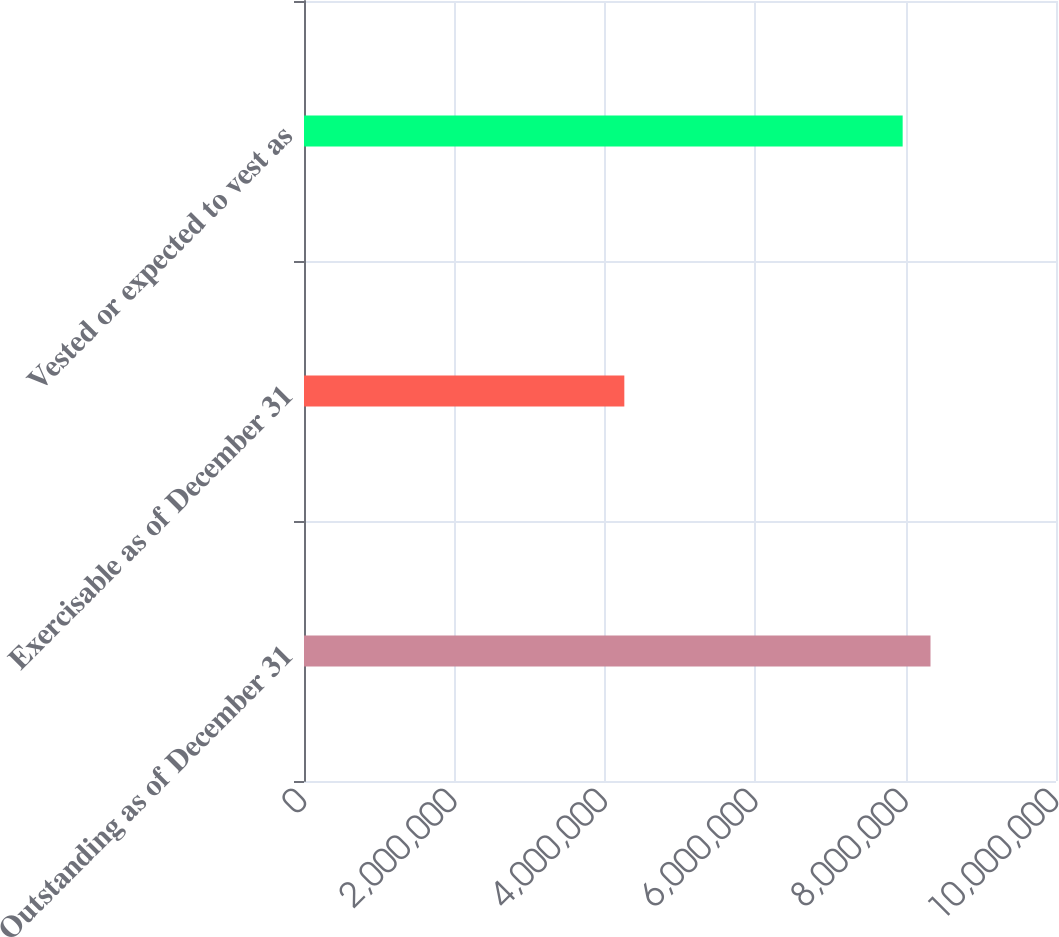<chart> <loc_0><loc_0><loc_500><loc_500><bar_chart><fcel>Outstanding as of December 31<fcel>Exercisable as of December 31<fcel>Vested or expected to vest as<nl><fcel>8.33117e+06<fcel>4.25965e+06<fcel>7.96088e+06<nl></chart> 